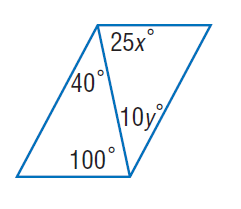Question: Find y so that the quadrilateral is a parallelogram.
Choices:
A. 4
B. 8
C. 12
D. 16
Answer with the letter. Answer: A 